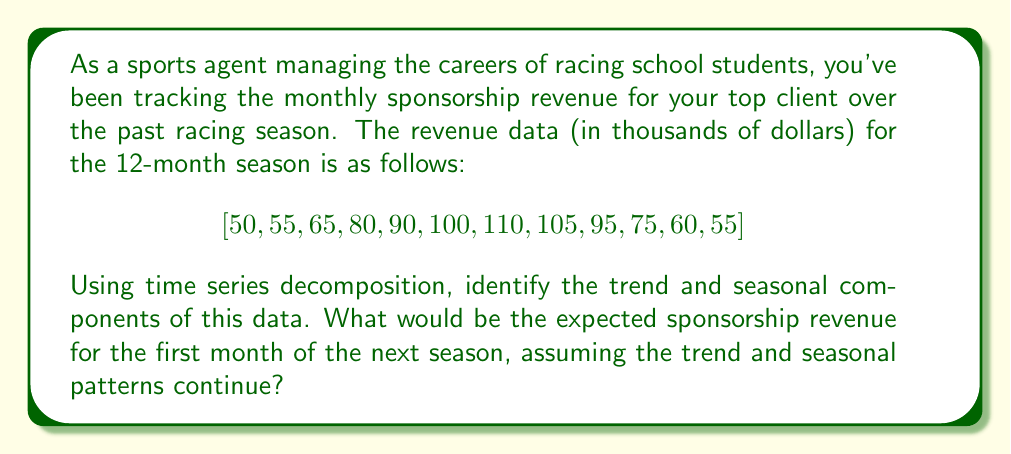Help me with this question. To solve this problem, we'll use the additive time series decomposition method, which assumes that the time series can be broken down into three components: trend, seasonality, and residuals.

1. Calculate the centered moving average (CMA) to estimate the trend:
   First, we calculate a 12-month moving average, then center it:
   $CMA = [77.5, 80.0, 82.5, 85.0, 87.5, 90.0, 91.7, 92.5, 91.7, 90.0]$

2. Estimate the seasonal component:
   Subtract the CMA from the original data to get the seasonal plus residual component.
   Calculate the average for each month across seasons (we only have one season here).

3. Adjust the seasonal component:
   Ensure that the seasonal components sum to zero by subtracting their mean.
   Seasonal components: $[-27.5, -25.0, -17.5, -5.0, 2.5, 10.0, 18.3, 12.5, 3.3, -15.0, -30.0, -35.0]$

4. Calculate the trend component:
   Fit a linear regression to the CMA values.
   Trend equation: $T_t = 76.25 + 1.65t$, where $t$ is the month number (1 to 12)

5. Project the trend and seasonal components for the first month of the next season:
   Trend for month 13: $T_{13} = 76.25 + 1.65 * 13 = 97.70$
   Seasonal component for the first month: $-27.5$

6. Sum the projected trend and seasonal components:
   Expected revenue = Trend + Seasonal
   $97.70 + (-27.5) = 70.20$
Answer: The expected sponsorship revenue for the first month of the next season is approximately $70,200. 